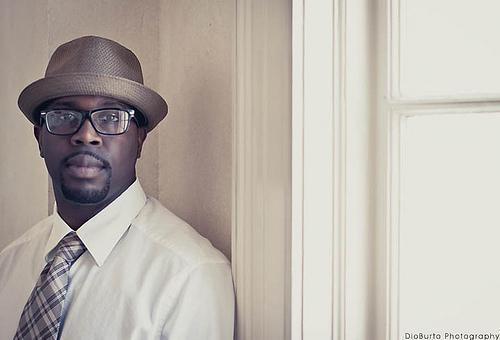How many people are in this picture?
Give a very brief answer. 1. 